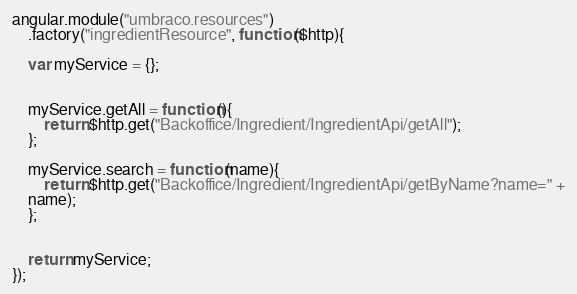Convert code to text. <code><loc_0><loc_0><loc_500><loc_500><_JavaScript_>angular.module("umbraco.resources")
	.factory("ingredientResource", function($http){

	var myService = {};	
	
	
	myService.getAll = function(){
		return $http.get("Backoffice/Ingredient/IngredientApi/getAll");
	};

	myService.search = function(name){
		return $http.get("Backoffice/Ingredient/IngredientApi/getByName?name=" +
	name);
	};


	return myService;
});
</code> 